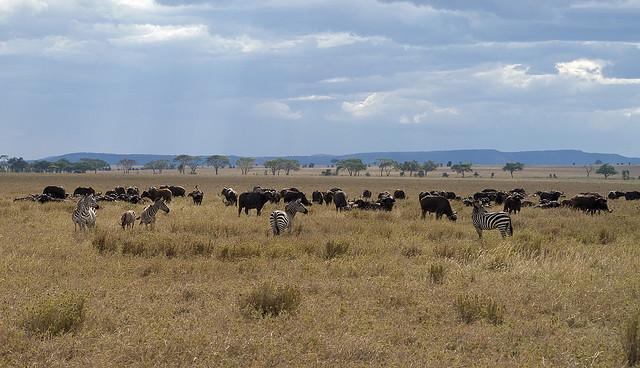How many zebras can be seen?
Give a very brief answer. 4. How many remotes are there?
Give a very brief answer. 0. 